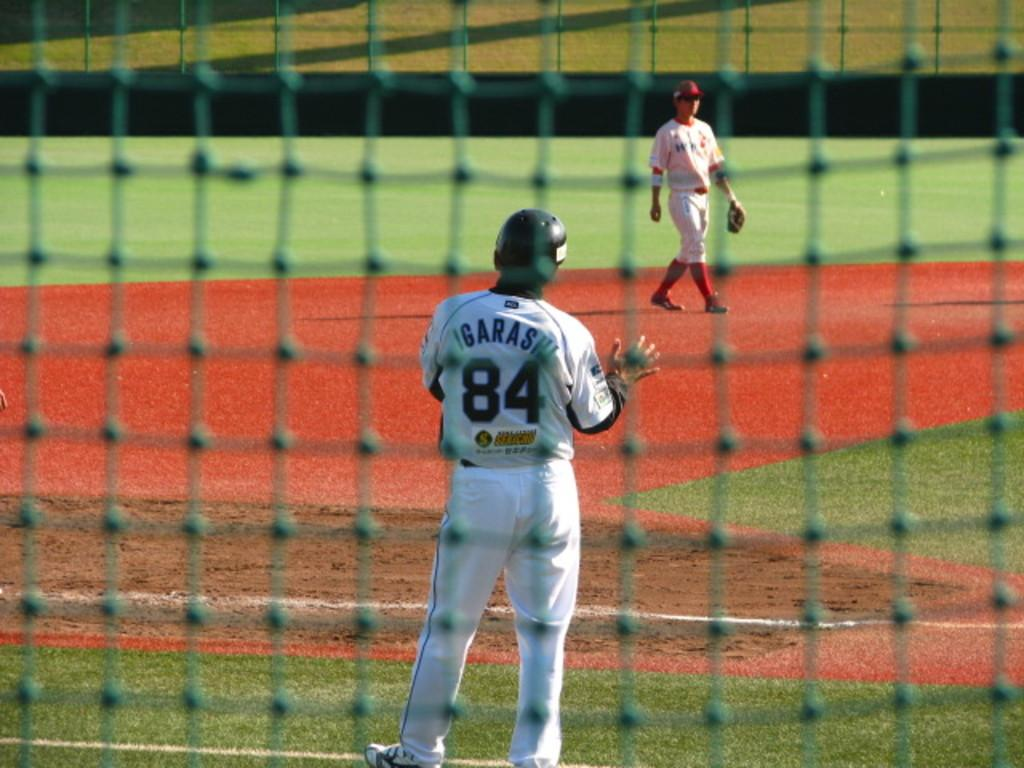<image>
Render a clear and concise summary of the photo. The baseball player named Igarashi wears the number 84 jersey. 